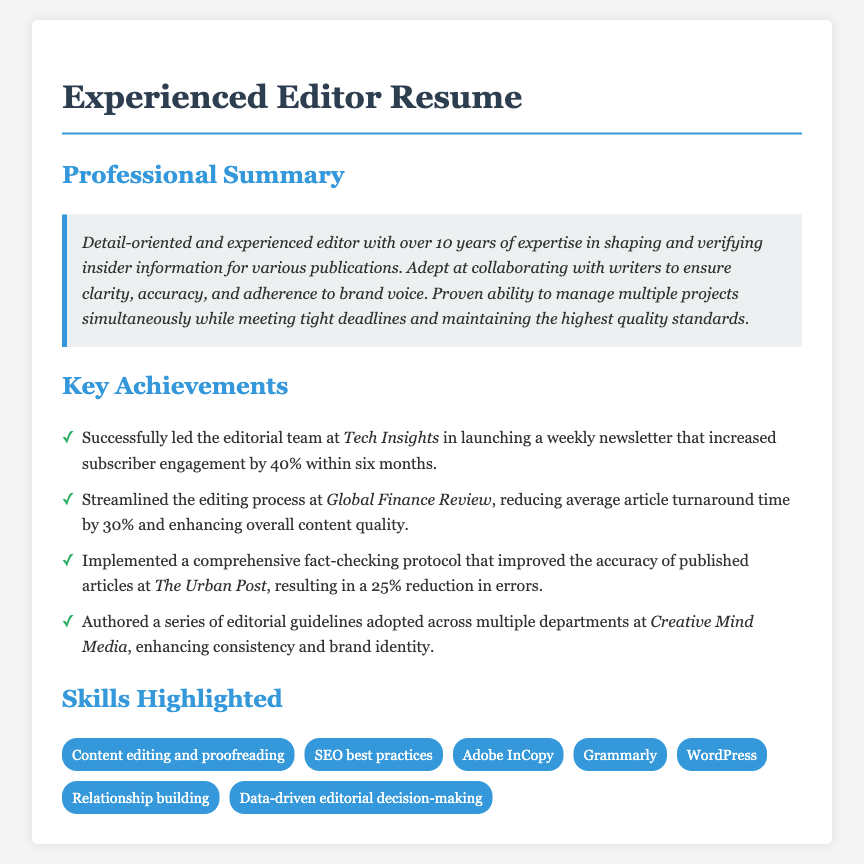What is the editor's years of experience? The document states that the editor has over 10 years of expertise.
Answer: over 10 years Which publication did the editor lead a newsletter for? The achievement mentions the editor led a newsletter at Tech Insights.
Answer: Tech Insights What was the percentage increase in subscriber engagement? The document indicates a 40% increase in subscriber engagement within six months.
Answer: 40% What editing tool is mentioned in the skills? The skills section lists Adobe InCopy as one of the tools.
Answer: Adobe InCopy How much did the article turnaround time reduce by? The document states that the average article turnaround time was reduced by 30%.
Answer: 30% What improved accuracy protocol did the editor implement? The document mentions the implementation of a comprehensive fact-checking protocol.
Answer: fact-checking protocol Which two key skills are highlighted in the resume? The skills listed include content editing and proofreading, SEO best practices, among others.
Answer: content editing and proofreading, SEO best practices What is the primary focus of the professional summary? The professional summary emphasizes shaping and verifying insider information for publications.
Answer: shaping and verifying insider information How many achievements are listed in the document? There are four key achievements outlined in the document.
Answer: 4 